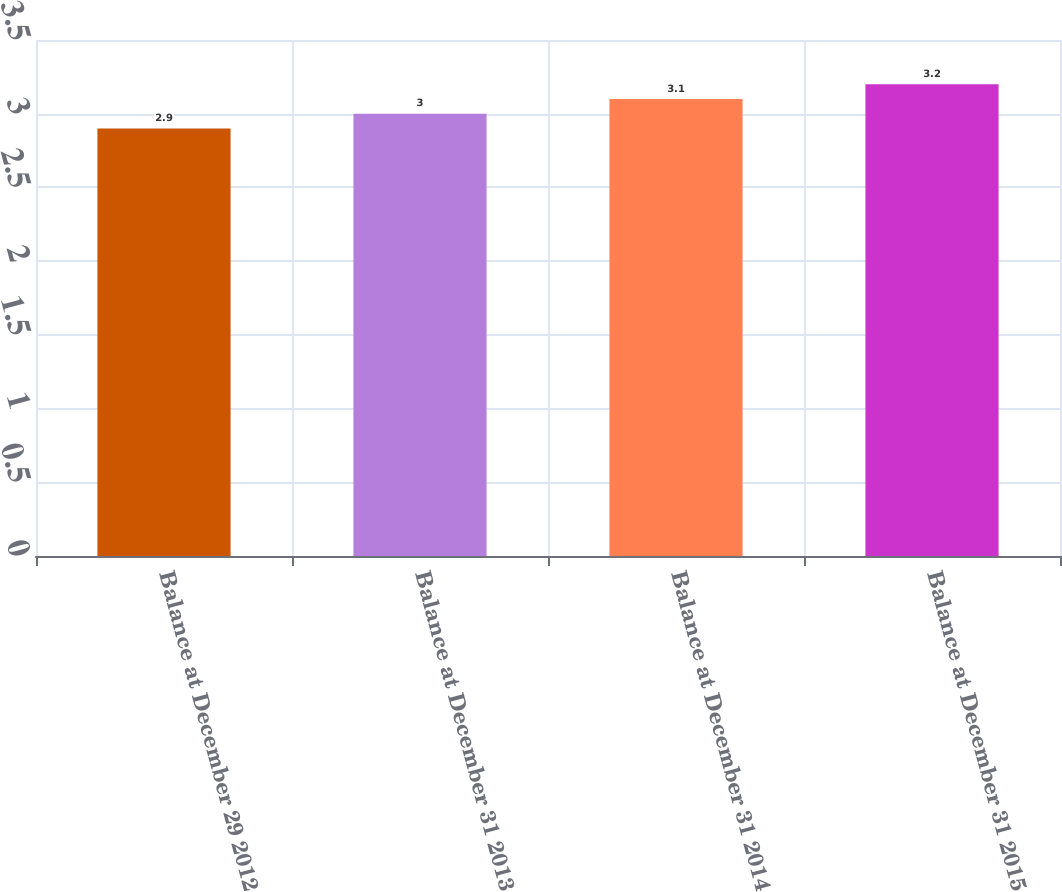<chart> <loc_0><loc_0><loc_500><loc_500><bar_chart><fcel>Balance at December 29 2012<fcel>Balance at December 31 2013<fcel>Balance at December 31 2014<fcel>Balance at December 31 2015<nl><fcel>2.9<fcel>3<fcel>3.1<fcel>3.2<nl></chart> 